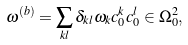Convert formula to latex. <formula><loc_0><loc_0><loc_500><loc_500>\omega ^ { ( b ) } = \sum _ { k l } \delta _ { k l } \omega _ { k } c ^ { k } _ { 0 } c ^ { l } _ { 0 } \in \Omega _ { 0 } ^ { 2 } ,</formula> 